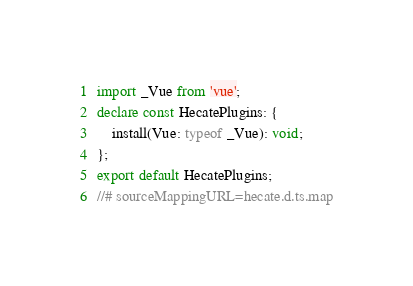Convert code to text. <code><loc_0><loc_0><loc_500><loc_500><_TypeScript_>import _Vue from 'vue';
declare const HecatePlugins: {
    install(Vue: typeof _Vue): void;
};
export default HecatePlugins;
//# sourceMappingURL=hecate.d.ts.map</code> 